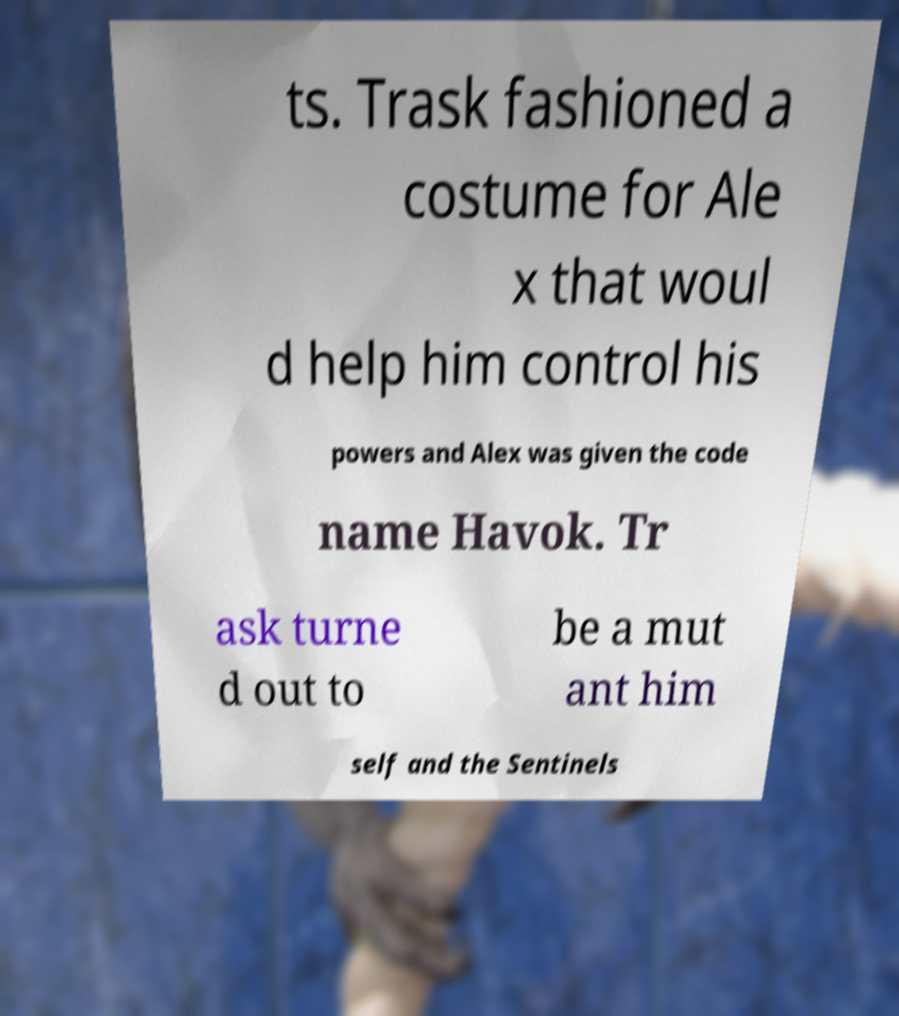I need the written content from this picture converted into text. Can you do that? ts. Trask fashioned a costume for Ale x that woul d help him control his powers and Alex was given the code name Havok. Tr ask turne d out to be a mut ant him self and the Sentinels 